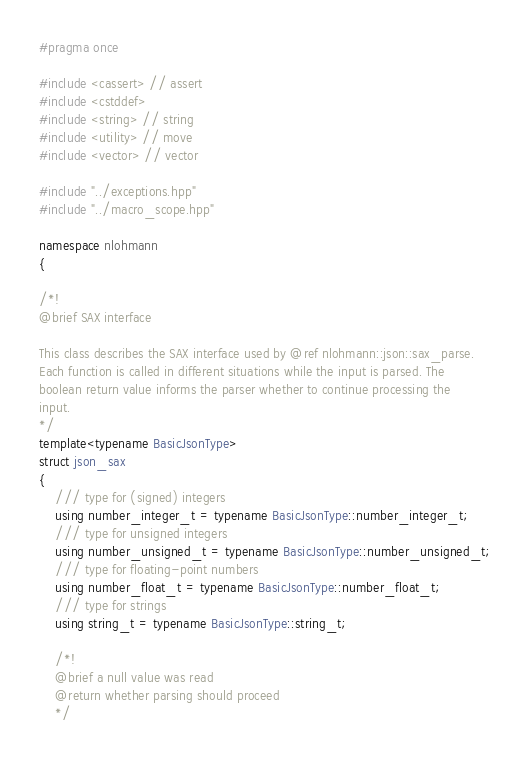Convert code to text. <code><loc_0><loc_0><loc_500><loc_500><_C++_>#pragma once

#include <cassert> // assert
#include <cstddef>
#include <string> // string
#include <utility> // move
#include <vector> // vector

#include "../exceptions.hpp"
#include "../macro_scope.hpp"

namespace nlohmann
{

/*!
@brief SAX interface

This class describes the SAX interface used by @ref nlohmann::json::sax_parse.
Each function is called in different situations while the input is parsed. The
boolean return value informs the parser whether to continue processing the
input.
*/
template<typename BasicJsonType>
struct json_sax
{
    /// type for (signed) integers
    using number_integer_t = typename BasicJsonType::number_integer_t;
    /// type for unsigned integers
    using number_unsigned_t = typename BasicJsonType::number_unsigned_t;
    /// type for floating-point numbers
    using number_float_t = typename BasicJsonType::number_float_t;
    /// type for strings
    using string_t = typename BasicJsonType::string_t;

    /*!
    @brief a null value was read
    @return whether parsing should proceed
    */</code> 